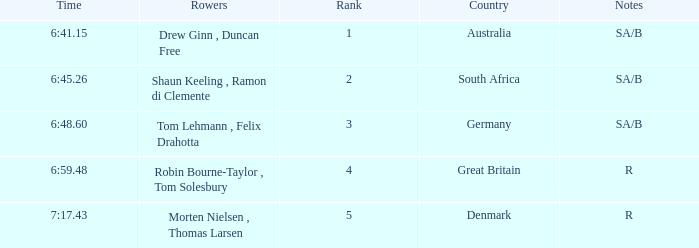What was the top position for rowers who represented denmark? 5.0. 